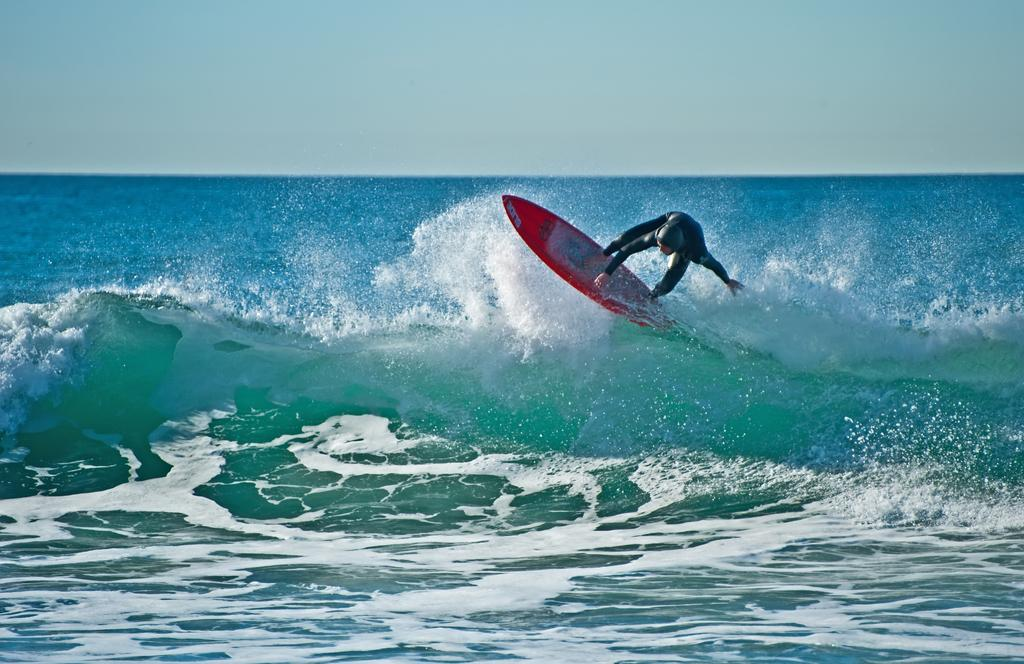Who is the main subject in the image? There is a person in the image. What is the person doing in the image? The person is surfing on a surfboard. Where is the surfboard located in the image? The surfboard is on the water. What can be seen in the background of the image? The sky is visible in the background of the image. What type of statement is being made by the surfboard in the image? The surfboard is not making any statements in the image; it is an inanimate object being used by the person for surfing. 